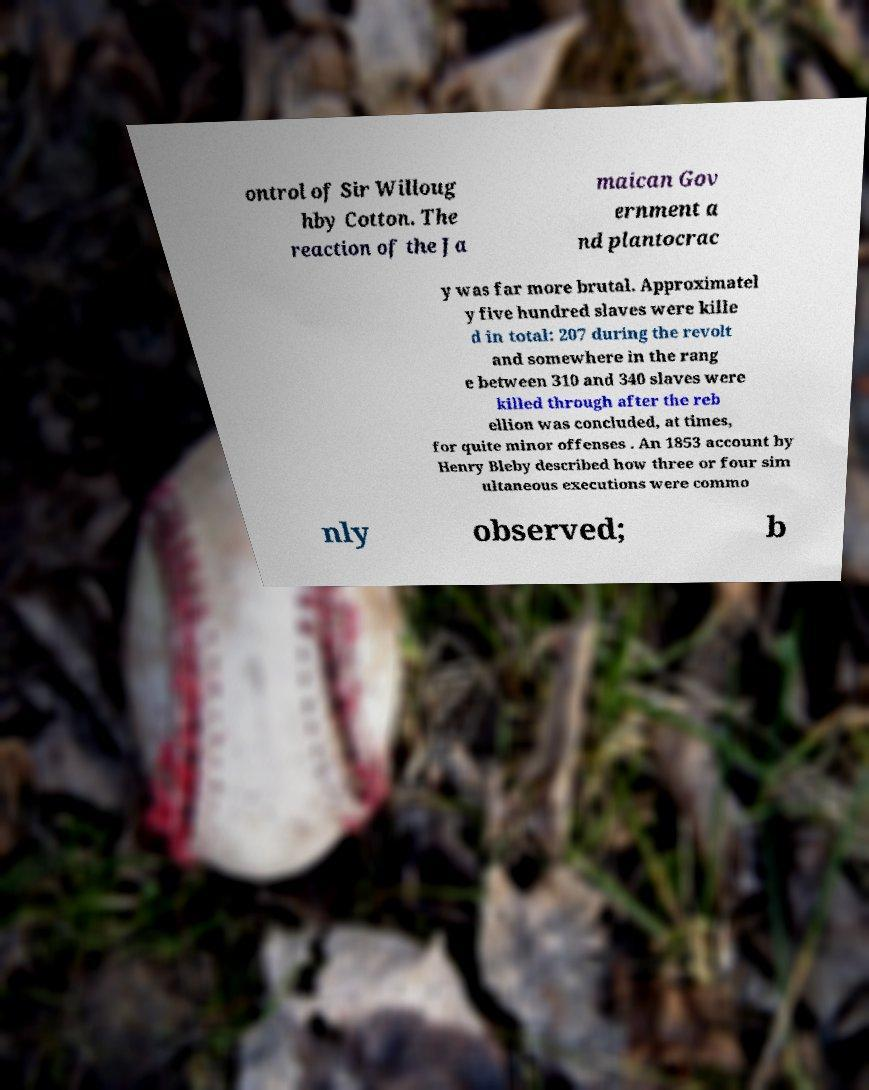I need the written content from this picture converted into text. Can you do that? ontrol of Sir Willoug hby Cotton. The reaction of the Ja maican Gov ernment a nd plantocrac y was far more brutal. Approximatel y five hundred slaves were kille d in total: 207 during the revolt and somewhere in the rang e between 310 and 340 slaves were killed through after the reb ellion was concluded, at times, for quite minor offenses . An 1853 account by Henry Bleby described how three or four sim ultaneous executions were commo nly observed; b 